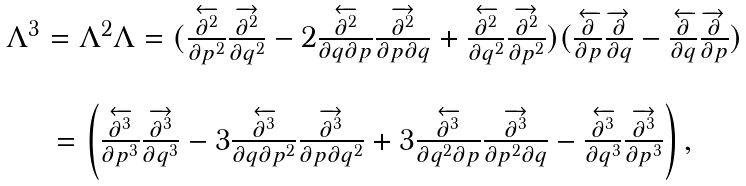<formula> <loc_0><loc_0><loc_500><loc_500>\begin{array} [ c ] { c } \Lambda ^ { 3 } = \Lambda ^ { 2 } \Lambda = ( \frac { \overleftarrow { \partial ^ { 2 } } } { \partial p ^ { 2 } } \frac { \overrightarrow { \partial ^ { 2 } } } { \partial q ^ { 2 } } - 2 \frac { \overleftarrow { \partial ^ { 2 } } } { \partial q \partial p } \frac { \overrightarrow { \partial ^ { 2 } } } { \partial p \partial q } + \frac { \overleftarrow { \partial ^ { 2 } } } { \partial q ^ { 2 } } \frac { \overrightarrow { \partial ^ { 2 } } } { \partial p ^ { 2 } } ) ( \frac { \overleftarrow { \partial } } { \partial p } \frac { \overrightarrow { \partial } } { \partial q } - \frac { \overleftarrow { \partial } } { \partial q } \frac { \overrightarrow { \partial } } { \partial p } ) \\ \\ = \left ( \frac { \overleftarrow { \partial ^ { 3 } } } { \partial p ^ { 3 } } \frac { \overrightarrow { \partial ^ { 3 } } } { \partial q ^ { 3 } } - 3 \frac { \overleftarrow { \partial ^ { 3 } } } { \partial q \partial p ^ { 2 } } \frac { \overrightarrow { \partial ^ { 3 } } } { \partial p \partial q ^ { 2 } } + 3 \frac { \overleftarrow { \partial ^ { 3 } } } { \partial q ^ { 2 } \partial p } \frac { \overrightarrow { \partial ^ { 3 } } } { \partial p ^ { 2 } \partial q } - \frac { \overleftarrow { \partial ^ { 3 } } } { \partial q ^ { 3 } } \frac { \overrightarrow { \partial ^ { 3 } } } { \partial p ^ { 3 } } \right ) , \end{array}</formula> 